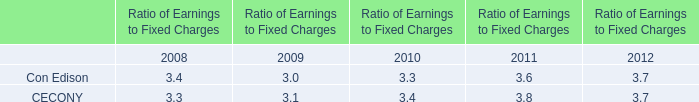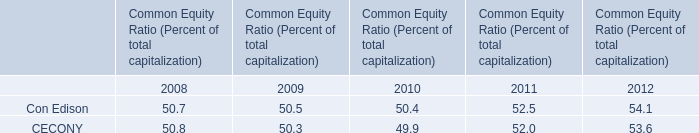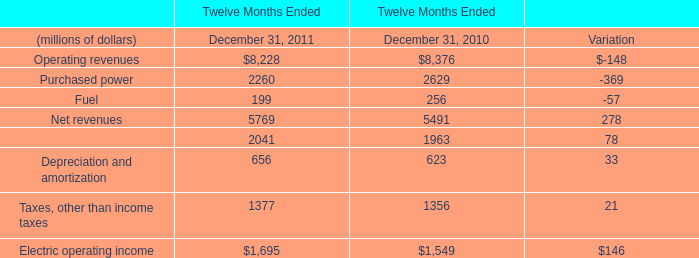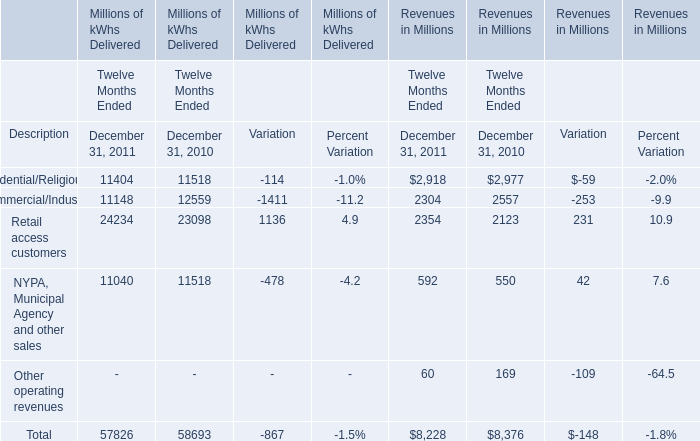What will Commercial/Industrial in revenues be like in 2011 if it develops with the same increasing rate as current? (in million) 
Computations: ((((2304 - 2557) / 2557) + 1) * 2304)
Answer: 2076.03285. 